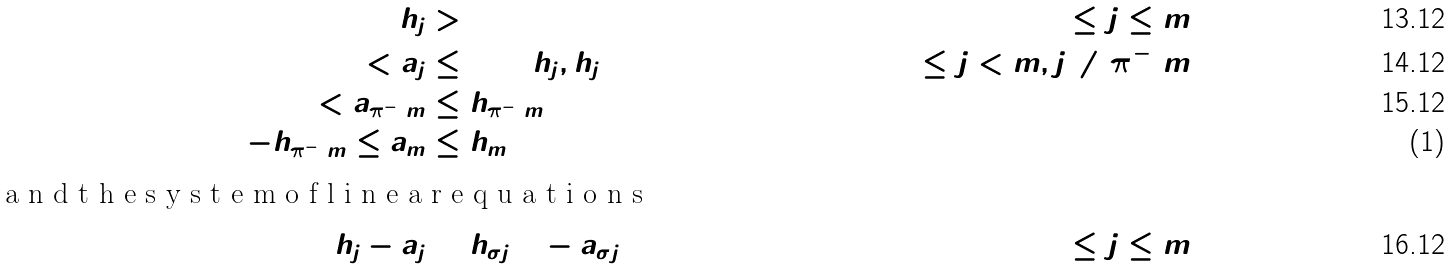Convert formula to latex. <formula><loc_0><loc_0><loc_500><loc_500>h _ { j } & > 0 & ( 1 \leq j \leq m ) \\ 0 < a _ { j } & \leq \min ( h _ { j } , h _ { j + 1 } ) & ( 1 \leq j < m , j \neq \pi ^ { - 1 } m ) \\ 0 < a _ { \pi ^ { - 1 } m } & \leq h _ { \pi ^ { - 1 } m + 1 } & \\ - h _ { \pi ^ { - 1 } m } \leq a _ { m } & \leq h _ { m } & \intertext { a n d t h e s y s t e m o f l i n e a r e q u a t i o n s } h _ { j } - a _ { j } & = h _ { \sigma j + 1 } - a _ { \sigma j } & ( 0 \leq j \leq m )</formula> 